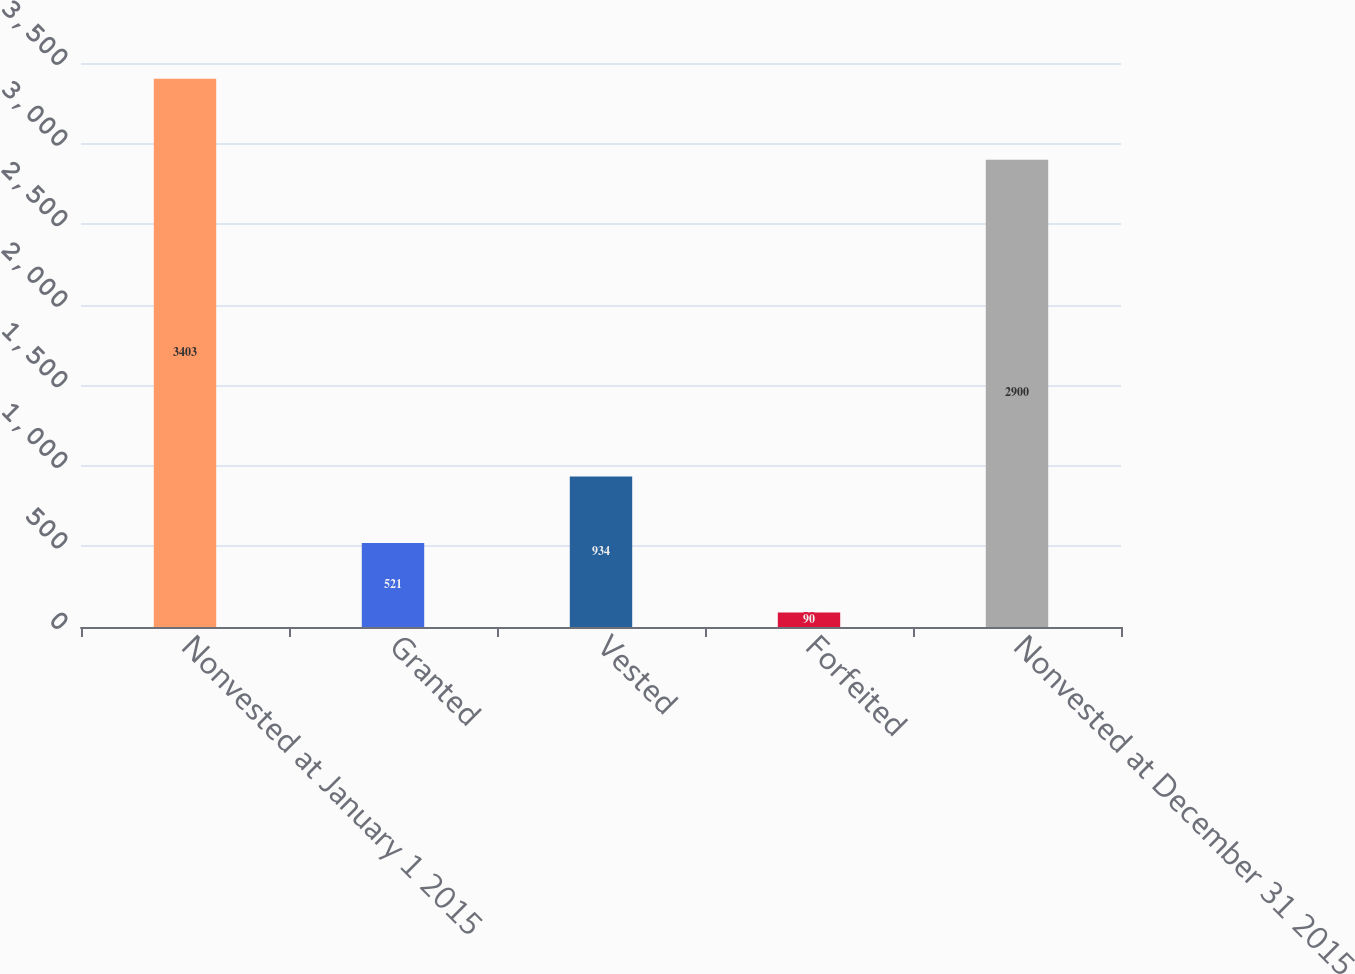<chart> <loc_0><loc_0><loc_500><loc_500><bar_chart><fcel>Nonvested at January 1 2015<fcel>Granted<fcel>Vested<fcel>Forfeited<fcel>Nonvested at December 31 2015<nl><fcel>3403<fcel>521<fcel>934<fcel>90<fcel>2900<nl></chart> 